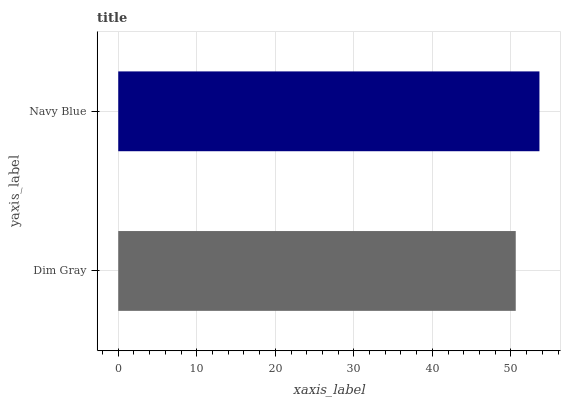Is Dim Gray the minimum?
Answer yes or no. Yes. Is Navy Blue the maximum?
Answer yes or no. Yes. Is Navy Blue the minimum?
Answer yes or no. No. Is Navy Blue greater than Dim Gray?
Answer yes or no. Yes. Is Dim Gray less than Navy Blue?
Answer yes or no. Yes. Is Dim Gray greater than Navy Blue?
Answer yes or no. No. Is Navy Blue less than Dim Gray?
Answer yes or no. No. Is Navy Blue the high median?
Answer yes or no. Yes. Is Dim Gray the low median?
Answer yes or no. Yes. Is Dim Gray the high median?
Answer yes or no. No. Is Navy Blue the low median?
Answer yes or no. No. 